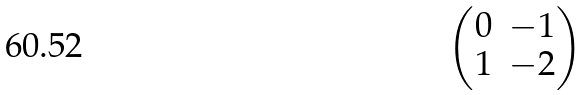<formula> <loc_0><loc_0><loc_500><loc_500>\begin{pmatrix} 0 & - 1 \\ 1 & - 2 \end{pmatrix}</formula> 